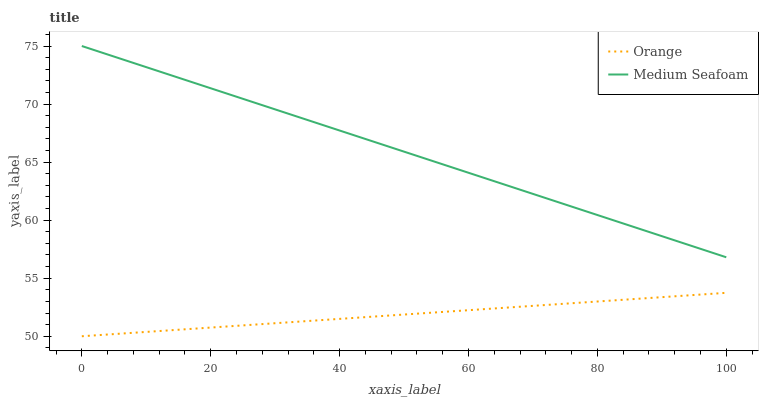Does Orange have the minimum area under the curve?
Answer yes or no. Yes. Does Medium Seafoam have the maximum area under the curve?
Answer yes or no. Yes. Does Medium Seafoam have the minimum area under the curve?
Answer yes or no. No. Is Medium Seafoam the smoothest?
Answer yes or no. Yes. Is Orange the roughest?
Answer yes or no. Yes. Is Medium Seafoam the roughest?
Answer yes or no. No. Does Orange have the lowest value?
Answer yes or no. Yes. Does Medium Seafoam have the lowest value?
Answer yes or no. No. Does Medium Seafoam have the highest value?
Answer yes or no. Yes. Is Orange less than Medium Seafoam?
Answer yes or no. Yes. Is Medium Seafoam greater than Orange?
Answer yes or no. Yes. Does Orange intersect Medium Seafoam?
Answer yes or no. No. 